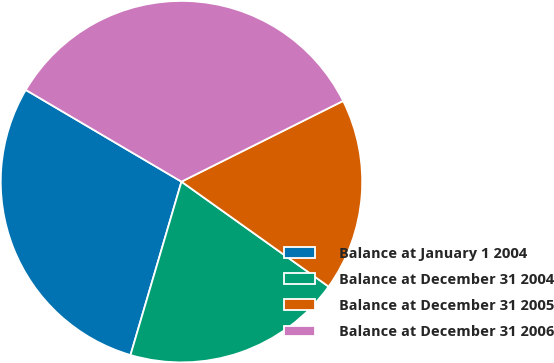Convert chart. <chart><loc_0><loc_0><loc_500><loc_500><pie_chart><fcel>Balance at January 1 2004<fcel>Balance at December 31 2004<fcel>Balance at December 31 2005<fcel>Balance at December 31 2006<nl><fcel>28.92%<fcel>19.69%<fcel>17.23%<fcel>34.15%<nl></chart> 